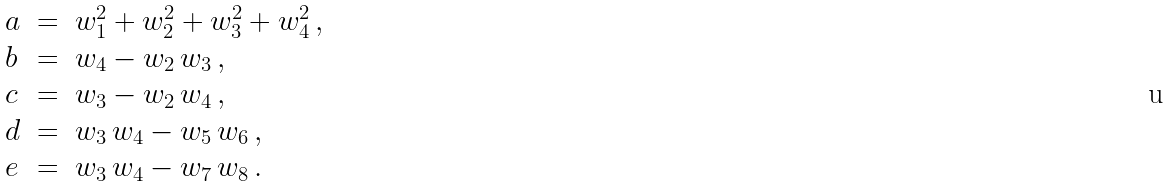Convert formula to latex. <formula><loc_0><loc_0><loc_500><loc_500>\begin{array} { l l l } a & = & w _ { 1 } ^ { 2 } + w _ { 2 } ^ { 2 } + w _ { 3 } ^ { 2 } + w _ { 4 } ^ { 2 } \, , \\ b & = & w _ { 4 } - w _ { 2 } \, w _ { 3 } \, , \\ c & = & w _ { 3 } - w _ { 2 } \, w _ { 4 } \, , \\ d & = & w _ { 3 } \, w _ { 4 } - w _ { 5 } \, w _ { 6 } \, , \\ e & = & w _ { 3 } \, w _ { 4 } - w _ { 7 } \, w _ { 8 } \, . \end{array}</formula> 